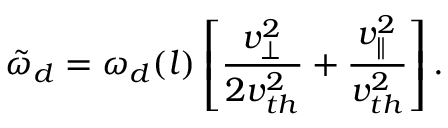<formula> <loc_0><loc_0><loc_500><loc_500>\tilde { \omega } _ { d } = \omega _ { d } ( l ) \left [ \frac { v _ { \perp } ^ { 2 } } { 2 v _ { t h } ^ { 2 } } + \frac { v _ { \| } ^ { 2 } } { v _ { t h } ^ { 2 } } \right ] .</formula> 